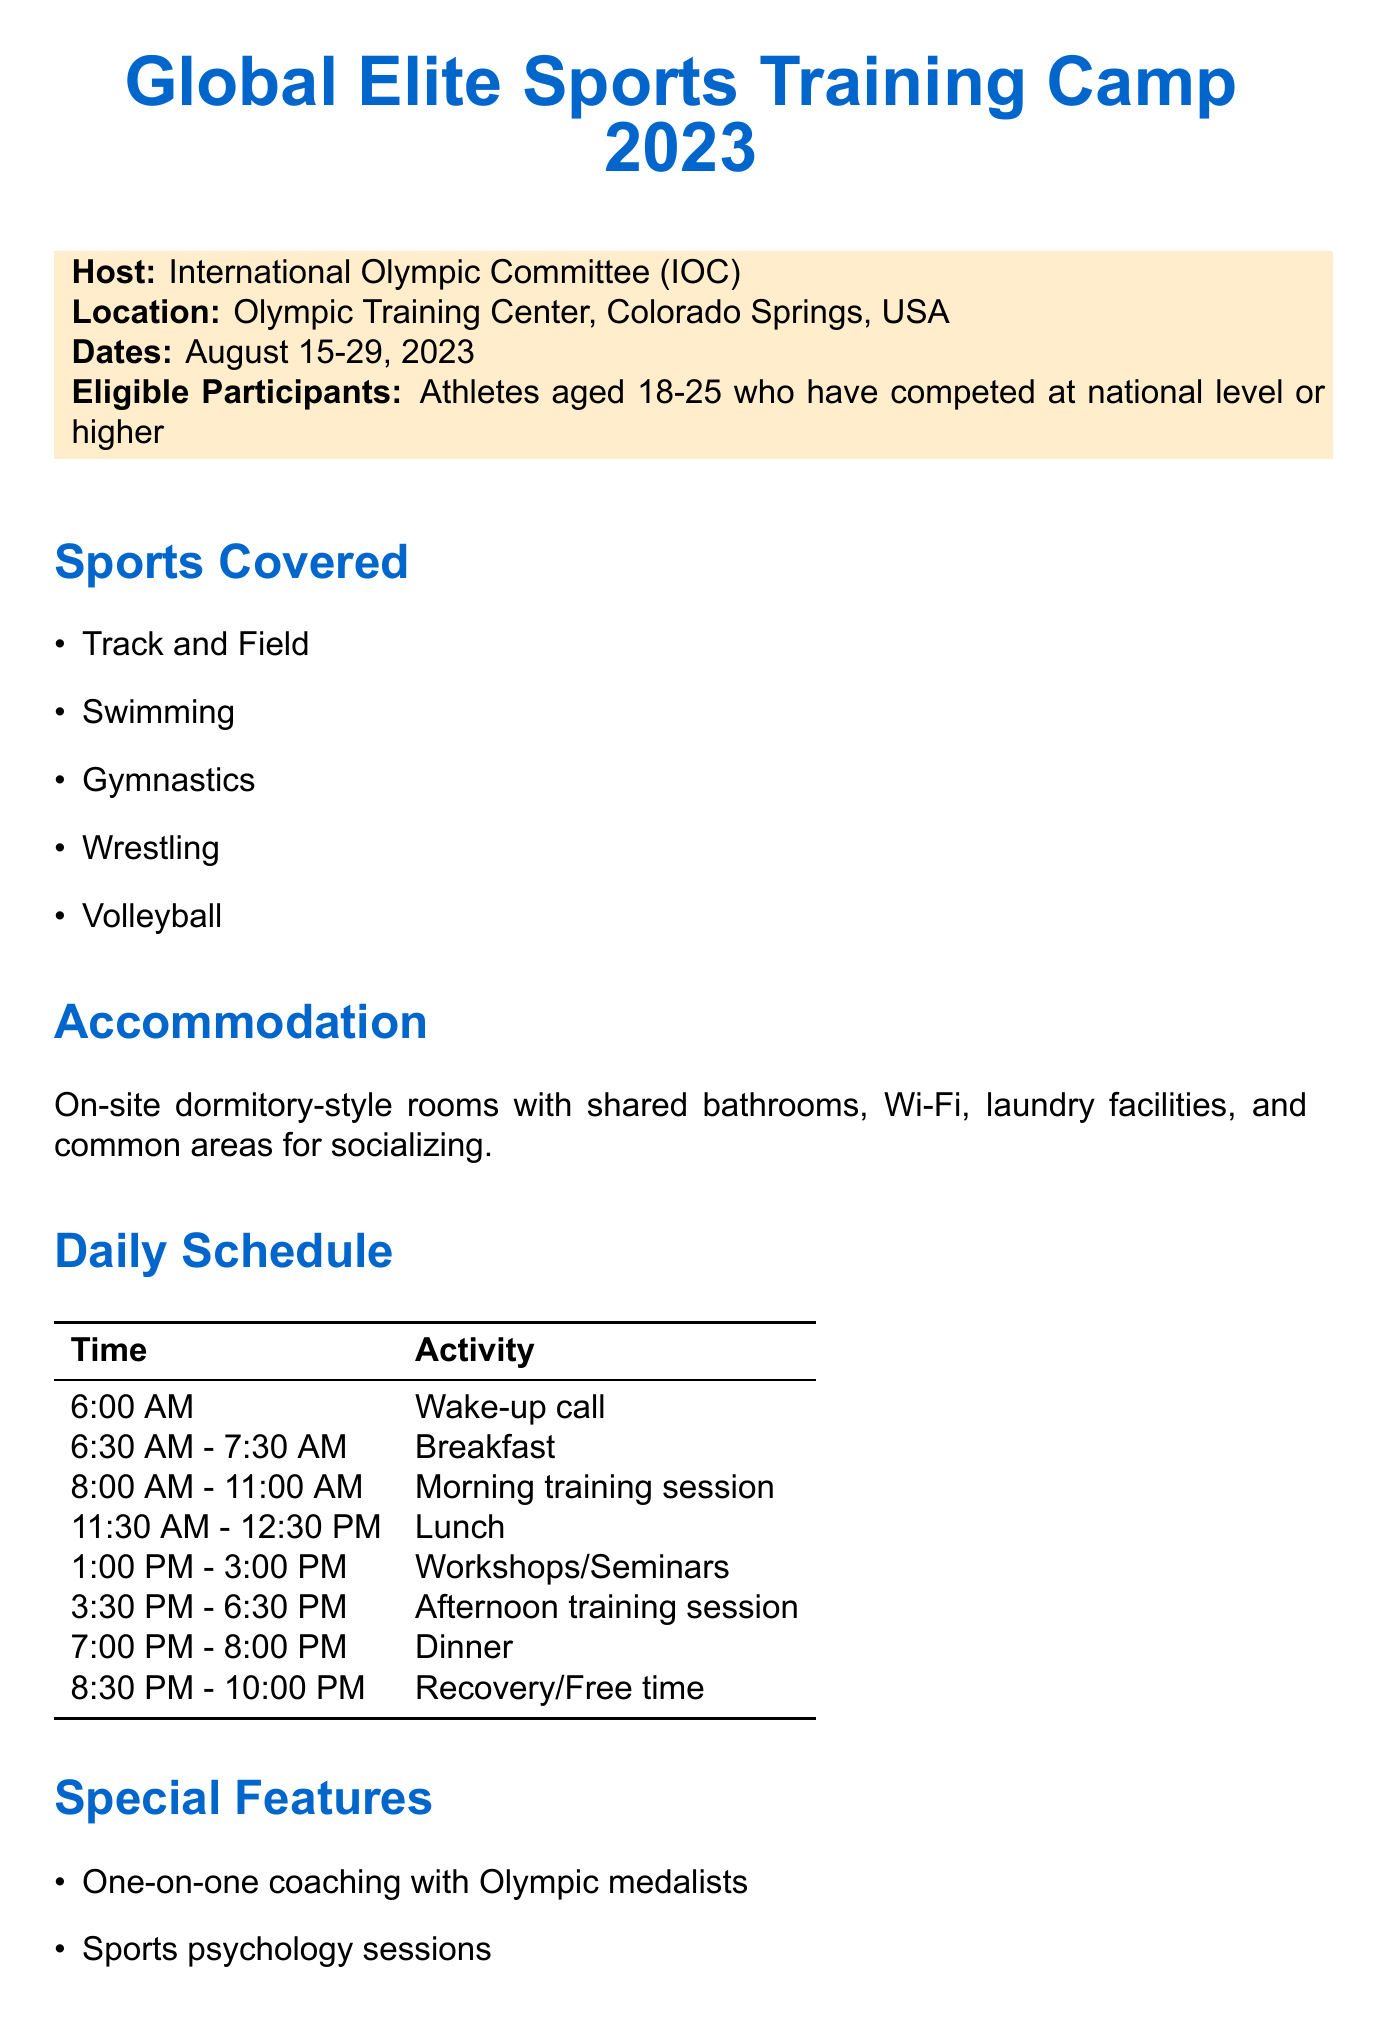What is the host organization for the event? The host organization is mentioned at the beginning of the document as the International Olympic Committee (IOC).
Answer: International Olympic Committee (IOC) What are the dates of the training camp? The document specifies the dates prominently, indicating when the event will take place.
Answer: August 15-29, 2023 Who is the contact person for inquiries? The contact person is listed in the section about applications, providing the necessary information for further communication.
Answer: Sarah Thompson What types of accommodation are provided? The document describes the accommodation type in the corresponding section related to that topic.
Answer: On-site dormitory-style rooms What age group is eligible to participate? The eligibility criteria for participants are clearly stated in the document's introductory section.
Answer: 18-25 How many daily training sessions are scheduled? The daily schedule outlines the number of training sessions throughout the day and adds up the morning and afternoon sessions.
Answer: Two What special feature includes coaching from specific athletes? The document's section on special features highlights the coaching element with notable athletes.
Answer: One-on-one coaching with Olympic medalists What activities are scheduled for the afternoon slots? The daily schedule outlines specific activities during the afternoon, including training sessions and workshops.
Answer: Afternoon training session What is the application deadline? The deadline for submitting applications is stated at the end of the document, making it easily identifiable.
Answer: June 30, 2023 